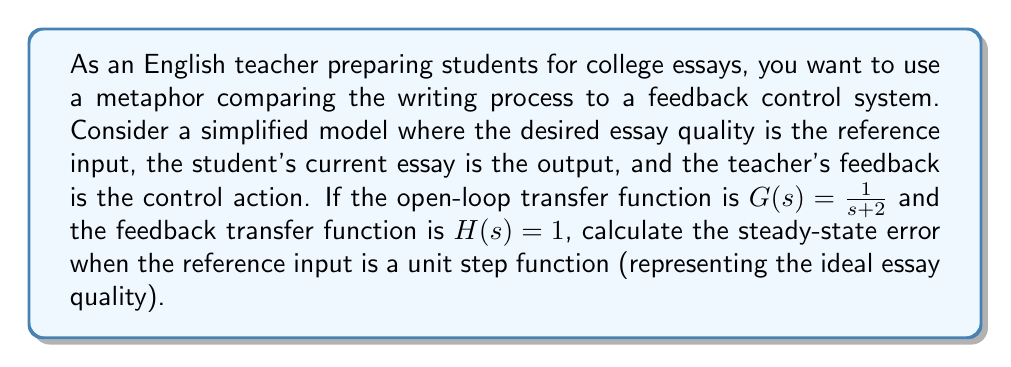What is the answer to this math problem? To solve this problem, we'll follow these steps:

1) First, we need to determine the system type. The open-loop transfer function $G(s) = \frac{1}{s+2}$ has no free integrators, so it's a Type 0 system.

2) For a Type 0 system, the steady-state error for a step input is given by:

   $$e_{ss} = \frac{1}{1 + K_p}$$

   where $K_p$ is the position error constant.

3) To find $K_p$, we use the formula:

   $$K_p = \lim_{s \to 0} G(s)H(s)$$

4) Substituting our transfer functions:

   $$K_p = \lim_{s \to 0} \frac{1}{s+2} \cdot 1 = \frac{1}{2}$$

5) Now we can calculate the steady-state error:

   $$e_{ss} = \frac{1}{1 + K_p} = \frac{1}{1 + \frac{1}{2}} = \frac{2}{3}$$

6) This means that the steady-state error is $\frac{2}{3}$ or approximately 0.667.

In the context of essay writing, this suggests that with this feedback system, the student's essay quality will approach about 33.3% of the ideal quality in the long term, leaving room for continued improvement.
Answer: The steady-state error is $\frac{2}{3}$ or approximately 0.667. 